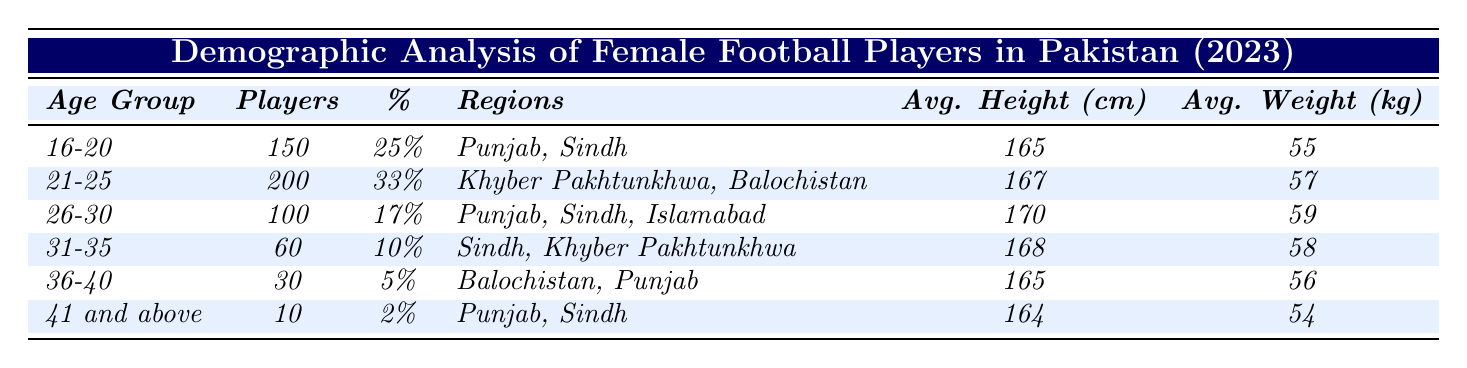What is the age group with the highest number of players? The age group with the highest number of players is 21-25, which has 200 players listed in the table.
Answer: 21-25 What percentage of players are aged 36-40? The age group 36-40 has 5% of the total players, as shown in the percentage column of the table.
Answer: 5% Which region has the least number of players? The age group 41 and above has the least number of players with only 10 players, found in the number of players column.
Answer: Punjab, Sindh What is the average height of players aged 26-30? The average height for the age group 26-30 is 170 cm, as indicated in the average height column.
Answer: 170 cm How many players are there in the 31-35 age group? There are 60 players in the 31-35 age group, directly referred to in the number of players column.
Answer: 60 What is the difference in the average weight between the 16-20 and 21-25 age groups? The average weight of the 16-20 age group is 55 kg and for 21-25 it is 57 kg. The difference is 57 kg - 55 kg = 2 kg.
Answer: 2 kg Is the average height of players in the 41 and above category less than 165 cm? The average height for the 41 and above group is 164 cm, which is indeed less than 165 cm, making this statement true.
Answer: Yes What is the total number of players across all age groups in the table? To find the total, add the number of players in each age group: 150 + 200 + 100 + 60 + 30 + 10 = 550.
Answer: 550 Which age group has more players: 16-20 or 26-30? In the 16-20 age group, there are 150 players, while in the 26-30 age group, there are 100 players. Since 150 is greater than 100, the 16-20 age group has more players.
Answer: 16-20 What is the average weight of the youngest age group? The average weight of the youngest age group, 16-20, is 55 kg, as stated in the average weight column for that age group.
Answer: 55 kg What is the combined average height of players aged 31-35 and 36-40? The average height for 31-35 is 168 cm and for 36-40, it is 165 cm. To find the combined average, we add them (168 + 165) and divide by 2. Resulting calculation: (168 + 165) / 2 = 166.5 cm.
Answer: 166.5 cm 